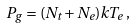<formula> <loc_0><loc_0><loc_500><loc_500>P _ { g } = ( N _ { t } + N _ { e } ) k T _ { e } \, ,</formula> 